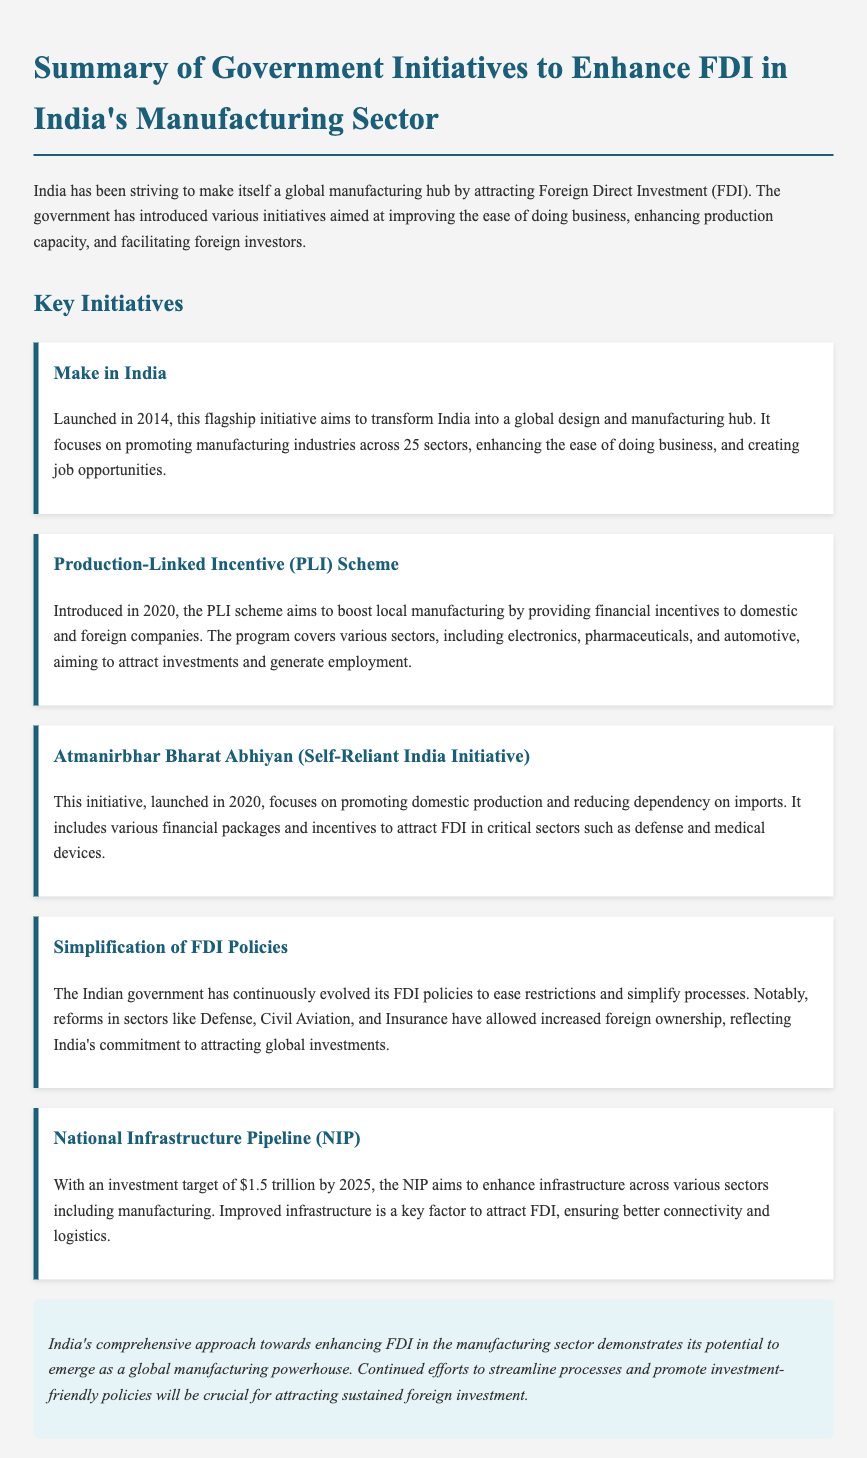What is the name of the flagship initiative launched in 2014? The document states that "Make in India" is the flagship initiative launched in 2014 aimed at transforming India into a global design and manufacturing hub.
Answer: Make in India When was the Production-Linked Incentive (PLI) Scheme introduced? According to the note, the PLI scheme was introduced in 2020.
Answer: 2020 What does the Atmanirbhar Bharat Abhiyan aim to promote? The note indicates that the Atmanirbhar Bharat Abhiyan focuses on promoting domestic production and reducing dependency on imports.
Answer: Domestic production How much is the investment target set by the National Infrastructure Pipeline (NIP) by 2025? The document mentions the investment target of the NIP is $1.5 trillion by 2025.
Answer: $1.5 trillion Which sectors has the Indian government reformed to allow increased foreign ownership? The note lists Defense, Civil Aviation, and Insurance as sectors where FDI policies have been simplified and restrictions eased.
Answer: Defense, Civil Aviation, Insurance What is the primary goal of the Make in India initiative? Based on the document, the primary goal of the Make in India initiative is to promote manufacturing industries across 25 sectors.
Answer: Promote manufacturing industries Which initiative was launched specifically to attract foreign investments in critical sectors? The document states that the Atmanirbhar Bharat Abhiyan includes financial packages and incentives aimed at attracting FDI in critical sectors.
Answer: Atmanirbhar Bharat Abhiyan What is the underlying strategy of the government's initiatives regarding FDI in manufacturing? The note indicates that the comprehensive approach aims to enhance FDI in the manufacturing sector by streamlining processes and promoting investment-friendly policies.
Answer: Streamlining processes and promoting investment-friendly policies 